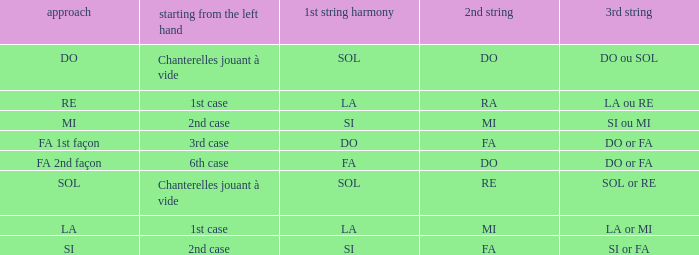Could you parse the entire table? {'header': ['approach', 'starting from the left hand', '1st string harmony', '2nd string', '3rd string'], 'rows': [['DO', 'Chanterelles jouant à vide', 'SOL', 'DO', 'DO ou SOL'], ['RE', '1st case', 'LA', 'RA', 'LA ou RE'], ['MI', '2nd case', 'SI', 'MI', 'SI ou MI'], ['FA 1st façon', '3rd case', 'DO', 'FA', 'DO or FA'], ['FA 2nd façon', '6th case', 'FA', 'DO', 'DO or FA'], ['SOL', 'Chanterelles jouant à vide', 'SOL', 'RE', 'SOL or RE'], ['LA', '1st case', 'LA', 'MI', 'LA or MI'], ['SI', '2nd case', 'SI', 'FA', 'SI or FA']]} What is the Depart de la main gauche of the do Mode? Chanterelles jouant à vide. 